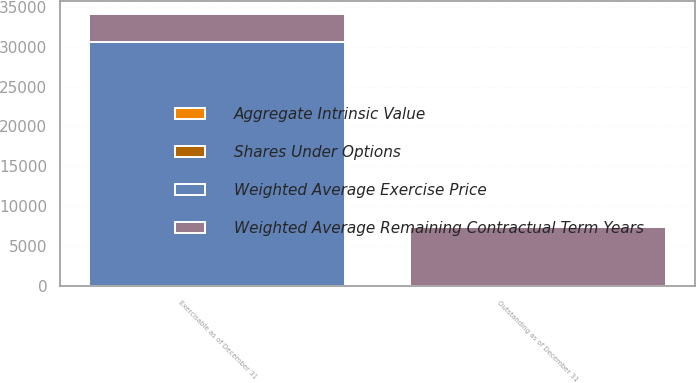Convert chart to OTSL. <chart><loc_0><loc_0><loc_500><loc_500><stacked_bar_chart><ecel><fcel>Outstanding as of December 31<fcel>Exercisable as of December 31<nl><fcel>Weighted Average Remaining Contractual Term Years<fcel>7319<fcel>3430<nl><fcel>Aggregate Intrinsic Value<fcel>27.71<fcel>28.12<nl><fcel>Shares Under Options<fcel>6.6<fcel>5.1<nl><fcel>Weighted Average Exercise Price<fcel>28.12<fcel>30562<nl></chart> 